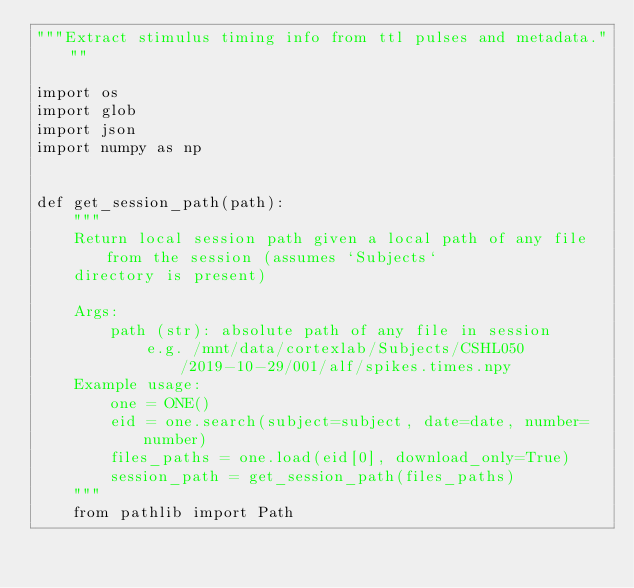<code> <loc_0><loc_0><loc_500><loc_500><_Python_>"""Extract stimulus timing info from ttl pulses and metadata."""

import os
import glob
import json
import numpy as np


def get_session_path(path):
    """
    Return local session path given a local path of any file from the session (assumes `Subjects`
    directory is present)

    Args:
        path (str): absolute path of any file in session
            e.g. /mnt/data/cortexlab/Subjects/CSHL050/2019-10-29/001/alf/spikes.times.npy
    Example usage:
        one = ONE()
        eid = one.search(subject=subject, date=date, number=number)
        files_paths = one.load(eid[0], download_only=True)
        session_path = get_session_path(files_paths)
    """
    from pathlib import Path</code> 